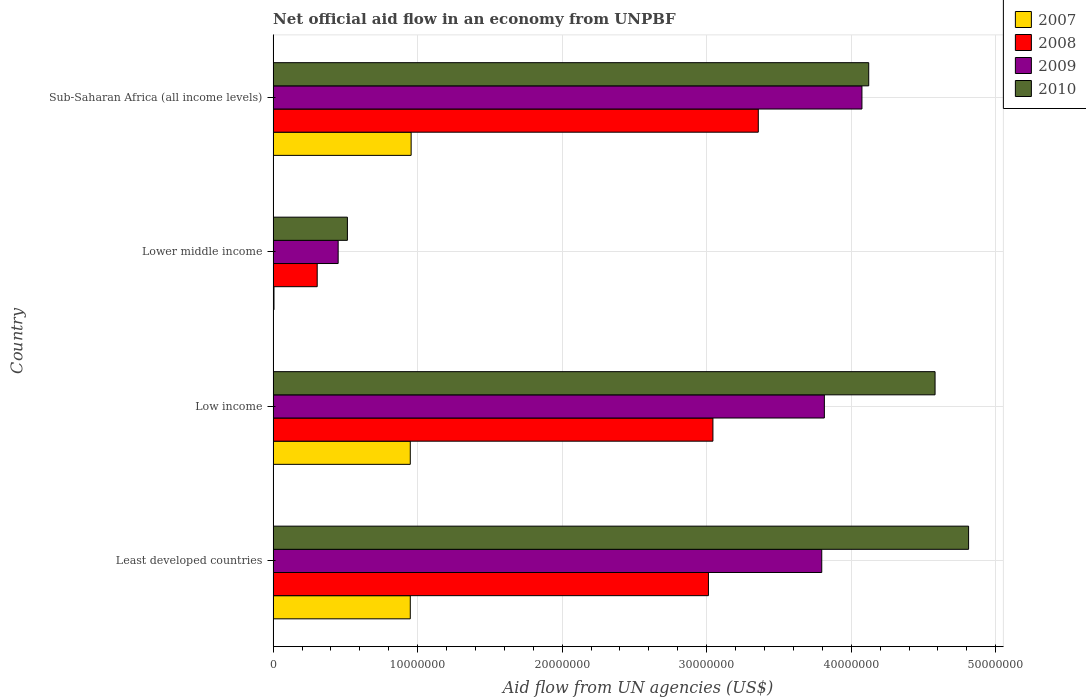How many groups of bars are there?
Offer a very short reply. 4. What is the label of the 4th group of bars from the top?
Offer a terse response. Least developed countries. In how many cases, is the number of bars for a given country not equal to the number of legend labels?
Your answer should be compact. 0. What is the net official aid flow in 2010 in Low income?
Ensure brevity in your answer.  4.58e+07. Across all countries, what is the maximum net official aid flow in 2010?
Give a very brief answer. 4.81e+07. Across all countries, what is the minimum net official aid flow in 2008?
Keep it short and to the point. 3.05e+06. In which country was the net official aid flow in 2009 maximum?
Provide a succinct answer. Sub-Saharan Africa (all income levels). In which country was the net official aid flow in 2009 minimum?
Offer a very short reply. Lower middle income. What is the total net official aid flow in 2009 in the graph?
Make the answer very short. 1.21e+08. What is the difference between the net official aid flow in 2010 in Least developed countries and that in Low income?
Offer a terse response. 2.32e+06. What is the difference between the net official aid flow in 2008 in Lower middle income and the net official aid flow in 2009 in Least developed countries?
Your answer should be compact. -3.49e+07. What is the average net official aid flow in 2008 per country?
Your response must be concise. 2.43e+07. What is the difference between the net official aid flow in 2009 and net official aid flow in 2010 in Low income?
Your response must be concise. -7.66e+06. In how many countries, is the net official aid flow in 2007 greater than 42000000 US$?
Your answer should be very brief. 0. What is the ratio of the net official aid flow in 2010 in Least developed countries to that in Low income?
Provide a succinct answer. 1.05. Is the difference between the net official aid flow in 2009 in Least developed countries and Low income greater than the difference between the net official aid flow in 2010 in Least developed countries and Low income?
Make the answer very short. No. What is the difference between the highest and the second highest net official aid flow in 2010?
Your response must be concise. 2.32e+06. What is the difference between the highest and the lowest net official aid flow in 2008?
Your answer should be compact. 3.05e+07. Is the sum of the net official aid flow in 2008 in Least developed countries and Lower middle income greater than the maximum net official aid flow in 2010 across all countries?
Provide a short and direct response. No. Is it the case that in every country, the sum of the net official aid flow in 2010 and net official aid flow in 2007 is greater than the sum of net official aid flow in 2008 and net official aid flow in 2009?
Keep it short and to the point. No. What does the 1st bar from the top in Sub-Saharan Africa (all income levels) represents?
Keep it short and to the point. 2010. What does the 1st bar from the bottom in Lower middle income represents?
Ensure brevity in your answer.  2007. Is it the case that in every country, the sum of the net official aid flow in 2007 and net official aid flow in 2010 is greater than the net official aid flow in 2008?
Keep it short and to the point. Yes. How many bars are there?
Offer a terse response. 16. Are all the bars in the graph horizontal?
Give a very brief answer. Yes. How many countries are there in the graph?
Keep it short and to the point. 4. Does the graph contain any zero values?
Provide a succinct answer. No. Does the graph contain grids?
Provide a short and direct response. Yes. Where does the legend appear in the graph?
Your response must be concise. Top right. What is the title of the graph?
Provide a short and direct response. Net official aid flow in an economy from UNPBF. Does "1982" appear as one of the legend labels in the graph?
Provide a short and direct response. No. What is the label or title of the X-axis?
Offer a terse response. Aid flow from UN agencies (US$). What is the Aid flow from UN agencies (US$) in 2007 in Least developed countries?
Your response must be concise. 9.49e+06. What is the Aid flow from UN agencies (US$) of 2008 in Least developed countries?
Your response must be concise. 3.01e+07. What is the Aid flow from UN agencies (US$) in 2009 in Least developed countries?
Offer a very short reply. 3.80e+07. What is the Aid flow from UN agencies (US$) of 2010 in Least developed countries?
Your answer should be compact. 4.81e+07. What is the Aid flow from UN agencies (US$) in 2007 in Low income?
Your response must be concise. 9.49e+06. What is the Aid flow from UN agencies (US$) in 2008 in Low income?
Offer a terse response. 3.04e+07. What is the Aid flow from UN agencies (US$) of 2009 in Low income?
Offer a terse response. 3.81e+07. What is the Aid flow from UN agencies (US$) of 2010 in Low income?
Keep it short and to the point. 4.58e+07. What is the Aid flow from UN agencies (US$) in 2008 in Lower middle income?
Offer a terse response. 3.05e+06. What is the Aid flow from UN agencies (US$) in 2009 in Lower middle income?
Your answer should be compact. 4.50e+06. What is the Aid flow from UN agencies (US$) of 2010 in Lower middle income?
Make the answer very short. 5.14e+06. What is the Aid flow from UN agencies (US$) in 2007 in Sub-Saharan Africa (all income levels)?
Provide a succinct answer. 9.55e+06. What is the Aid flow from UN agencies (US$) of 2008 in Sub-Saharan Africa (all income levels)?
Ensure brevity in your answer.  3.36e+07. What is the Aid flow from UN agencies (US$) in 2009 in Sub-Saharan Africa (all income levels)?
Your response must be concise. 4.07e+07. What is the Aid flow from UN agencies (US$) in 2010 in Sub-Saharan Africa (all income levels)?
Your answer should be compact. 4.12e+07. Across all countries, what is the maximum Aid flow from UN agencies (US$) in 2007?
Offer a very short reply. 9.55e+06. Across all countries, what is the maximum Aid flow from UN agencies (US$) in 2008?
Your answer should be compact. 3.36e+07. Across all countries, what is the maximum Aid flow from UN agencies (US$) in 2009?
Provide a short and direct response. 4.07e+07. Across all countries, what is the maximum Aid flow from UN agencies (US$) in 2010?
Give a very brief answer. 4.81e+07. Across all countries, what is the minimum Aid flow from UN agencies (US$) in 2007?
Offer a very short reply. 6.00e+04. Across all countries, what is the minimum Aid flow from UN agencies (US$) in 2008?
Your response must be concise. 3.05e+06. Across all countries, what is the minimum Aid flow from UN agencies (US$) in 2009?
Ensure brevity in your answer.  4.50e+06. Across all countries, what is the minimum Aid flow from UN agencies (US$) in 2010?
Offer a terse response. 5.14e+06. What is the total Aid flow from UN agencies (US$) of 2007 in the graph?
Provide a succinct answer. 2.86e+07. What is the total Aid flow from UN agencies (US$) of 2008 in the graph?
Make the answer very short. 9.72e+07. What is the total Aid flow from UN agencies (US$) of 2009 in the graph?
Your answer should be compact. 1.21e+08. What is the total Aid flow from UN agencies (US$) of 2010 in the graph?
Your answer should be very brief. 1.40e+08. What is the difference between the Aid flow from UN agencies (US$) of 2008 in Least developed countries and that in Low income?
Ensure brevity in your answer.  -3.10e+05. What is the difference between the Aid flow from UN agencies (US$) of 2009 in Least developed countries and that in Low income?
Offer a terse response. -1.80e+05. What is the difference between the Aid flow from UN agencies (US$) of 2010 in Least developed countries and that in Low income?
Offer a very short reply. 2.32e+06. What is the difference between the Aid flow from UN agencies (US$) of 2007 in Least developed countries and that in Lower middle income?
Keep it short and to the point. 9.43e+06. What is the difference between the Aid flow from UN agencies (US$) of 2008 in Least developed countries and that in Lower middle income?
Ensure brevity in your answer.  2.71e+07. What is the difference between the Aid flow from UN agencies (US$) in 2009 in Least developed countries and that in Lower middle income?
Provide a short and direct response. 3.35e+07. What is the difference between the Aid flow from UN agencies (US$) in 2010 in Least developed countries and that in Lower middle income?
Your answer should be very brief. 4.30e+07. What is the difference between the Aid flow from UN agencies (US$) of 2008 in Least developed countries and that in Sub-Saharan Africa (all income levels)?
Offer a terse response. -3.45e+06. What is the difference between the Aid flow from UN agencies (US$) of 2009 in Least developed countries and that in Sub-Saharan Africa (all income levels)?
Give a very brief answer. -2.78e+06. What is the difference between the Aid flow from UN agencies (US$) in 2010 in Least developed countries and that in Sub-Saharan Africa (all income levels)?
Your answer should be very brief. 6.91e+06. What is the difference between the Aid flow from UN agencies (US$) in 2007 in Low income and that in Lower middle income?
Make the answer very short. 9.43e+06. What is the difference between the Aid flow from UN agencies (US$) of 2008 in Low income and that in Lower middle income?
Your answer should be compact. 2.74e+07. What is the difference between the Aid flow from UN agencies (US$) in 2009 in Low income and that in Lower middle income?
Give a very brief answer. 3.36e+07. What is the difference between the Aid flow from UN agencies (US$) in 2010 in Low income and that in Lower middle income?
Offer a terse response. 4.07e+07. What is the difference between the Aid flow from UN agencies (US$) in 2008 in Low income and that in Sub-Saharan Africa (all income levels)?
Your answer should be very brief. -3.14e+06. What is the difference between the Aid flow from UN agencies (US$) in 2009 in Low income and that in Sub-Saharan Africa (all income levels)?
Offer a terse response. -2.60e+06. What is the difference between the Aid flow from UN agencies (US$) of 2010 in Low income and that in Sub-Saharan Africa (all income levels)?
Offer a terse response. 4.59e+06. What is the difference between the Aid flow from UN agencies (US$) in 2007 in Lower middle income and that in Sub-Saharan Africa (all income levels)?
Offer a terse response. -9.49e+06. What is the difference between the Aid flow from UN agencies (US$) in 2008 in Lower middle income and that in Sub-Saharan Africa (all income levels)?
Make the answer very short. -3.05e+07. What is the difference between the Aid flow from UN agencies (US$) in 2009 in Lower middle income and that in Sub-Saharan Africa (all income levels)?
Provide a short and direct response. -3.62e+07. What is the difference between the Aid flow from UN agencies (US$) in 2010 in Lower middle income and that in Sub-Saharan Africa (all income levels)?
Offer a terse response. -3.61e+07. What is the difference between the Aid flow from UN agencies (US$) of 2007 in Least developed countries and the Aid flow from UN agencies (US$) of 2008 in Low income?
Ensure brevity in your answer.  -2.09e+07. What is the difference between the Aid flow from UN agencies (US$) of 2007 in Least developed countries and the Aid flow from UN agencies (US$) of 2009 in Low income?
Provide a short and direct response. -2.86e+07. What is the difference between the Aid flow from UN agencies (US$) of 2007 in Least developed countries and the Aid flow from UN agencies (US$) of 2010 in Low income?
Ensure brevity in your answer.  -3.63e+07. What is the difference between the Aid flow from UN agencies (US$) in 2008 in Least developed countries and the Aid flow from UN agencies (US$) in 2009 in Low income?
Offer a very short reply. -8.02e+06. What is the difference between the Aid flow from UN agencies (US$) in 2008 in Least developed countries and the Aid flow from UN agencies (US$) in 2010 in Low income?
Your response must be concise. -1.57e+07. What is the difference between the Aid flow from UN agencies (US$) of 2009 in Least developed countries and the Aid flow from UN agencies (US$) of 2010 in Low income?
Your answer should be very brief. -7.84e+06. What is the difference between the Aid flow from UN agencies (US$) of 2007 in Least developed countries and the Aid flow from UN agencies (US$) of 2008 in Lower middle income?
Keep it short and to the point. 6.44e+06. What is the difference between the Aid flow from UN agencies (US$) in 2007 in Least developed countries and the Aid flow from UN agencies (US$) in 2009 in Lower middle income?
Your response must be concise. 4.99e+06. What is the difference between the Aid flow from UN agencies (US$) of 2007 in Least developed countries and the Aid flow from UN agencies (US$) of 2010 in Lower middle income?
Your response must be concise. 4.35e+06. What is the difference between the Aid flow from UN agencies (US$) of 2008 in Least developed countries and the Aid flow from UN agencies (US$) of 2009 in Lower middle income?
Provide a succinct answer. 2.56e+07. What is the difference between the Aid flow from UN agencies (US$) in 2008 in Least developed countries and the Aid flow from UN agencies (US$) in 2010 in Lower middle income?
Your response must be concise. 2.50e+07. What is the difference between the Aid flow from UN agencies (US$) in 2009 in Least developed countries and the Aid flow from UN agencies (US$) in 2010 in Lower middle income?
Your answer should be very brief. 3.28e+07. What is the difference between the Aid flow from UN agencies (US$) of 2007 in Least developed countries and the Aid flow from UN agencies (US$) of 2008 in Sub-Saharan Africa (all income levels)?
Provide a succinct answer. -2.41e+07. What is the difference between the Aid flow from UN agencies (US$) in 2007 in Least developed countries and the Aid flow from UN agencies (US$) in 2009 in Sub-Saharan Africa (all income levels)?
Provide a succinct answer. -3.12e+07. What is the difference between the Aid flow from UN agencies (US$) in 2007 in Least developed countries and the Aid flow from UN agencies (US$) in 2010 in Sub-Saharan Africa (all income levels)?
Offer a terse response. -3.17e+07. What is the difference between the Aid flow from UN agencies (US$) in 2008 in Least developed countries and the Aid flow from UN agencies (US$) in 2009 in Sub-Saharan Africa (all income levels)?
Ensure brevity in your answer.  -1.06e+07. What is the difference between the Aid flow from UN agencies (US$) of 2008 in Least developed countries and the Aid flow from UN agencies (US$) of 2010 in Sub-Saharan Africa (all income levels)?
Offer a very short reply. -1.11e+07. What is the difference between the Aid flow from UN agencies (US$) of 2009 in Least developed countries and the Aid flow from UN agencies (US$) of 2010 in Sub-Saharan Africa (all income levels)?
Give a very brief answer. -3.25e+06. What is the difference between the Aid flow from UN agencies (US$) of 2007 in Low income and the Aid flow from UN agencies (US$) of 2008 in Lower middle income?
Give a very brief answer. 6.44e+06. What is the difference between the Aid flow from UN agencies (US$) of 2007 in Low income and the Aid flow from UN agencies (US$) of 2009 in Lower middle income?
Give a very brief answer. 4.99e+06. What is the difference between the Aid flow from UN agencies (US$) in 2007 in Low income and the Aid flow from UN agencies (US$) in 2010 in Lower middle income?
Give a very brief answer. 4.35e+06. What is the difference between the Aid flow from UN agencies (US$) in 2008 in Low income and the Aid flow from UN agencies (US$) in 2009 in Lower middle income?
Provide a short and direct response. 2.59e+07. What is the difference between the Aid flow from UN agencies (US$) in 2008 in Low income and the Aid flow from UN agencies (US$) in 2010 in Lower middle income?
Provide a succinct answer. 2.53e+07. What is the difference between the Aid flow from UN agencies (US$) of 2009 in Low income and the Aid flow from UN agencies (US$) of 2010 in Lower middle income?
Offer a terse response. 3.30e+07. What is the difference between the Aid flow from UN agencies (US$) of 2007 in Low income and the Aid flow from UN agencies (US$) of 2008 in Sub-Saharan Africa (all income levels)?
Make the answer very short. -2.41e+07. What is the difference between the Aid flow from UN agencies (US$) in 2007 in Low income and the Aid flow from UN agencies (US$) in 2009 in Sub-Saharan Africa (all income levels)?
Give a very brief answer. -3.12e+07. What is the difference between the Aid flow from UN agencies (US$) in 2007 in Low income and the Aid flow from UN agencies (US$) in 2010 in Sub-Saharan Africa (all income levels)?
Your answer should be compact. -3.17e+07. What is the difference between the Aid flow from UN agencies (US$) of 2008 in Low income and the Aid flow from UN agencies (US$) of 2009 in Sub-Saharan Africa (all income levels)?
Provide a succinct answer. -1.03e+07. What is the difference between the Aid flow from UN agencies (US$) of 2008 in Low income and the Aid flow from UN agencies (US$) of 2010 in Sub-Saharan Africa (all income levels)?
Ensure brevity in your answer.  -1.08e+07. What is the difference between the Aid flow from UN agencies (US$) in 2009 in Low income and the Aid flow from UN agencies (US$) in 2010 in Sub-Saharan Africa (all income levels)?
Ensure brevity in your answer.  -3.07e+06. What is the difference between the Aid flow from UN agencies (US$) of 2007 in Lower middle income and the Aid flow from UN agencies (US$) of 2008 in Sub-Saharan Africa (all income levels)?
Your response must be concise. -3.35e+07. What is the difference between the Aid flow from UN agencies (US$) in 2007 in Lower middle income and the Aid flow from UN agencies (US$) in 2009 in Sub-Saharan Africa (all income levels)?
Keep it short and to the point. -4.07e+07. What is the difference between the Aid flow from UN agencies (US$) of 2007 in Lower middle income and the Aid flow from UN agencies (US$) of 2010 in Sub-Saharan Africa (all income levels)?
Make the answer very short. -4.12e+07. What is the difference between the Aid flow from UN agencies (US$) in 2008 in Lower middle income and the Aid flow from UN agencies (US$) in 2009 in Sub-Saharan Africa (all income levels)?
Keep it short and to the point. -3.77e+07. What is the difference between the Aid flow from UN agencies (US$) in 2008 in Lower middle income and the Aid flow from UN agencies (US$) in 2010 in Sub-Saharan Africa (all income levels)?
Provide a short and direct response. -3.82e+07. What is the difference between the Aid flow from UN agencies (US$) of 2009 in Lower middle income and the Aid flow from UN agencies (US$) of 2010 in Sub-Saharan Africa (all income levels)?
Provide a short and direct response. -3.67e+07. What is the average Aid flow from UN agencies (US$) in 2007 per country?
Your answer should be compact. 7.15e+06. What is the average Aid flow from UN agencies (US$) in 2008 per country?
Your response must be concise. 2.43e+07. What is the average Aid flow from UN agencies (US$) in 2009 per country?
Keep it short and to the point. 3.03e+07. What is the average Aid flow from UN agencies (US$) of 2010 per country?
Ensure brevity in your answer.  3.51e+07. What is the difference between the Aid flow from UN agencies (US$) in 2007 and Aid flow from UN agencies (US$) in 2008 in Least developed countries?
Ensure brevity in your answer.  -2.06e+07. What is the difference between the Aid flow from UN agencies (US$) of 2007 and Aid flow from UN agencies (US$) of 2009 in Least developed countries?
Provide a succinct answer. -2.85e+07. What is the difference between the Aid flow from UN agencies (US$) in 2007 and Aid flow from UN agencies (US$) in 2010 in Least developed countries?
Keep it short and to the point. -3.86e+07. What is the difference between the Aid flow from UN agencies (US$) of 2008 and Aid flow from UN agencies (US$) of 2009 in Least developed countries?
Your response must be concise. -7.84e+06. What is the difference between the Aid flow from UN agencies (US$) in 2008 and Aid flow from UN agencies (US$) in 2010 in Least developed countries?
Offer a very short reply. -1.80e+07. What is the difference between the Aid flow from UN agencies (US$) of 2009 and Aid flow from UN agencies (US$) of 2010 in Least developed countries?
Keep it short and to the point. -1.02e+07. What is the difference between the Aid flow from UN agencies (US$) in 2007 and Aid flow from UN agencies (US$) in 2008 in Low income?
Ensure brevity in your answer.  -2.09e+07. What is the difference between the Aid flow from UN agencies (US$) of 2007 and Aid flow from UN agencies (US$) of 2009 in Low income?
Offer a very short reply. -2.86e+07. What is the difference between the Aid flow from UN agencies (US$) of 2007 and Aid flow from UN agencies (US$) of 2010 in Low income?
Your response must be concise. -3.63e+07. What is the difference between the Aid flow from UN agencies (US$) in 2008 and Aid flow from UN agencies (US$) in 2009 in Low income?
Provide a succinct answer. -7.71e+06. What is the difference between the Aid flow from UN agencies (US$) of 2008 and Aid flow from UN agencies (US$) of 2010 in Low income?
Your response must be concise. -1.54e+07. What is the difference between the Aid flow from UN agencies (US$) in 2009 and Aid flow from UN agencies (US$) in 2010 in Low income?
Your answer should be compact. -7.66e+06. What is the difference between the Aid flow from UN agencies (US$) in 2007 and Aid flow from UN agencies (US$) in 2008 in Lower middle income?
Keep it short and to the point. -2.99e+06. What is the difference between the Aid flow from UN agencies (US$) of 2007 and Aid flow from UN agencies (US$) of 2009 in Lower middle income?
Give a very brief answer. -4.44e+06. What is the difference between the Aid flow from UN agencies (US$) of 2007 and Aid flow from UN agencies (US$) of 2010 in Lower middle income?
Provide a short and direct response. -5.08e+06. What is the difference between the Aid flow from UN agencies (US$) in 2008 and Aid flow from UN agencies (US$) in 2009 in Lower middle income?
Your answer should be very brief. -1.45e+06. What is the difference between the Aid flow from UN agencies (US$) in 2008 and Aid flow from UN agencies (US$) in 2010 in Lower middle income?
Give a very brief answer. -2.09e+06. What is the difference between the Aid flow from UN agencies (US$) in 2009 and Aid flow from UN agencies (US$) in 2010 in Lower middle income?
Ensure brevity in your answer.  -6.40e+05. What is the difference between the Aid flow from UN agencies (US$) of 2007 and Aid flow from UN agencies (US$) of 2008 in Sub-Saharan Africa (all income levels)?
Provide a succinct answer. -2.40e+07. What is the difference between the Aid flow from UN agencies (US$) of 2007 and Aid flow from UN agencies (US$) of 2009 in Sub-Saharan Africa (all income levels)?
Provide a succinct answer. -3.12e+07. What is the difference between the Aid flow from UN agencies (US$) of 2007 and Aid flow from UN agencies (US$) of 2010 in Sub-Saharan Africa (all income levels)?
Make the answer very short. -3.17e+07. What is the difference between the Aid flow from UN agencies (US$) of 2008 and Aid flow from UN agencies (US$) of 2009 in Sub-Saharan Africa (all income levels)?
Provide a short and direct response. -7.17e+06. What is the difference between the Aid flow from UN agencies (US$) in 2008 and Aid flow from UN agencies (US$) in 2010 in Sub-Saharan Africa (all income levels)?
Offer a very short reply. -7.64e+06. What is the difference between the Aid flow from UN agencies (US$) of 2009 and Aid flow from UN agencies (US$) of 2010 in Sub-Saharan Africa (all income levels)?
Provide a succinct answer. -4.70e+05. What is the ratio of the Aid flow from UN agencies (US$) of 2010 in Least developed countries to that in Low income?
Your answer should be very brief. 1.05. What is the ratio of the Aid flow from UN agencies (US$) in 2007 in Least developed countries to that in Lower middle income?
Provide a succinct answer. 158.17. What is the ratio of the Aid flow from UN agencies (US$) in 2008 in Least developed countries to that in Lower middle income?
Your answer should be compact. 9.88. What is the ratio of the Aid flow from UN agencies (US$) in 2009 in Least developed countries to that in Lower middle income?
Provide a succinct answer. 8.44. What is the ratio of the Aid flow from UN agencies (US$) of 2010 in Least developed countries to that in Lower middle income?
Your answer should be very brief. 9.36. What is the ratio of the Aid flow from UN agencies (US$) in 2007 in Least developed countries to that in Sub-Saharan Africa (all income levels)?
Make the answer very short. 0.99. What is the ratio of the Aid flow from UN agencies (US$) in 2008 in Least developed countries to that in Sub-Saharan Africa (all income levels)?
Ensure brevity in your answer.  0.9. What is the ratio of the Aid flow from UN agencies (US$) of 2009 in Least developed countries to that in Sub-Saharan Africa (all income levels)?
Ensure brevity in your answer.  0.93. What is the ratio of the Aid flow from UN agencies (US$) in 2010 in Least developed countries to that in Sub-Saharan Africa (all income levels)?
Your response must be concise. 1.17. What is the ratio of the Aid flow from UN agencies (US$) of 2007 in Low income to that in Lower middle income?
Ensure brevity in your answer.  158.17. What is the ratio of the Aid flow from UN agencies (US$) of 2008 in Low income to that in Lower middle income?
Ensure brevity in your answer.  9.98. What is the ratio of the Aid flow from UN agencies (US$) in 2009 in Low income to that in Lower middle income?
Offer a very short reply. 8.48. What is the ratio of the Aid flow from UN agencies (US$) in 2010 in Low income to that in Lower middle income?
Make the answer very short. 8.91. What is the ratio of the Aid flow from UN agencies (US$) in 2007 in Low income to that in Sub-Saharan Africa (all income levels)?
Provide a succinct answer. 0.99. What is the ratio of the Aid flow from UN agencies (US$) of 2008 in Low income to that in Sub-Saharan Africa (all income levels)?
Ensure brevity in your answer.  0.91. What is the ratio of the Aid flow from UN agencies (US$) of 2009 in Low income to that in Sub-Saharan Africa (all income levels)?
Provide a short and direct response. 0.94. What is the ratio of the Aid flow from UN agencies (US$) of 2010 in Low income to that in Sub-Saharan Africa (all income levels)?
Give a very brief answer. 1.11. What is the ratio of the Aid flow from UN agencies (US$) in 2007 in Lower middle income to that in Sub-Saharan Africa (all income levels)?
Offer a terse response. 0.01. What is the ratio of the Aid flow from UN agencies (US$) of 2008 in Lower middle income to that in Sub-Saharan Africa (all income levels)?
Offer a very short reply. 0.09. What is the ratio of the Aid flow from UN agencies (US$) of 2009 in Lower middle income to that in Sub-Saharan Africa (all income levels)?
Your answer should be compact. 0.11. What is the ratio of the Aid flow from UN agencies (US$) in 2010 in Lower middle income to that in Sub-Saharan Africa (all income levels)?
Your answer should be compact. 0.12. What is the difference between the highest and the second highest Aid flow from UN agencies (US$) of 2008?
Ensure brevity in your answer.  3.14e+06. What is the difference between the highest and the second highest Aid flow from UN agencies (US$) of 2009?
Provide a short and direct response. 2.60e+06. What is the difference between the highest and the second highest Aid flow from UN agencies (US$) of 2010?
Your answer should be compact. 2.32e+06. What is the difference between the highest and the lowest Aid flow from UN agencies (US$) in 2007?
Your response must be concise. 9.49e+06. What is the difference between the highest and the lowest Aid flow from UN agencies (US$) of 2008?
Offer a very short reply. 3.05e+07. What is the difference between the highest and the lowest Aid flow from UN agencies (US$) of 2009?
Offer a terse response. 3.62e+07. What is the difference between the highest and the lowest Aid flow from UN agencies (US$) in 2010?
Make the answer very short. 4.30e+07. 